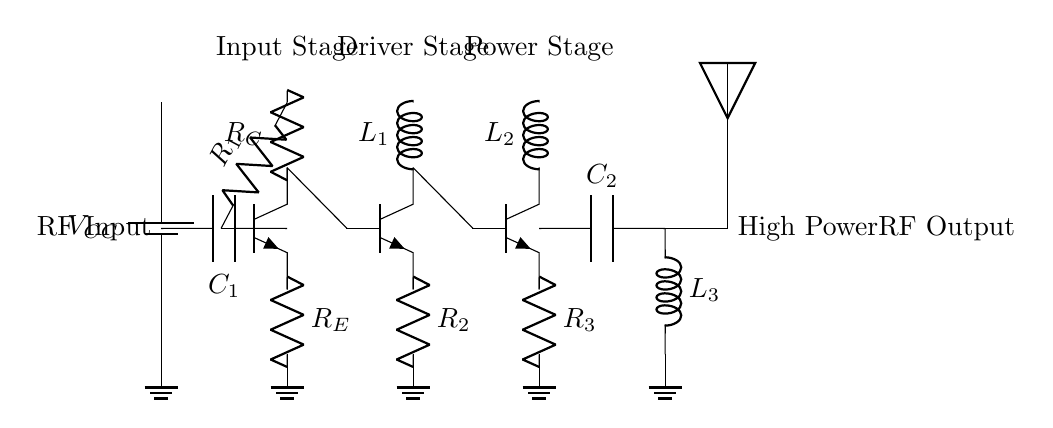What type of amplifier is shown in the circuit? The circuit is a power amplifier, indicated by the presence of multiple stages aimed at boosting the input signal to a high power output, suitable for jamming applications.
Answer: Power amplifier What is the role of the component labeled as C1? The coupling capacitor C1 is used to block DC voltage while allowing AC signals to pass, ensuring that the RF input signal can be amplified without DC bias affecting it.
Answer: Coupling How many stages does the amplifier have? The circuit consists of three stages; an input stage, a driver stage, and a power stage, each contributing to the overall signal amplification process.
Answer: Three stages What is the purpose of the output matching network? The output matching network comprises components C2 and L3, and its primary function is to match the output impedance of the amplifier to the antenna for maximum power transfer and efficiency in the RF output.
Answer: Impedance matching What is the total number of resistors in the circuit? The circuit features three resistors – R1, R2, and R3 – each serving to set the bias and load conditions for their respective transistor stages.
Answer: Three resistors What type of component is Q1? Q1 is a bipolar junction transistor (BJT), as indicated by its designation in the diagram, which is a common component used in amplifier circuits for signal amplification.
Answer: BJT 